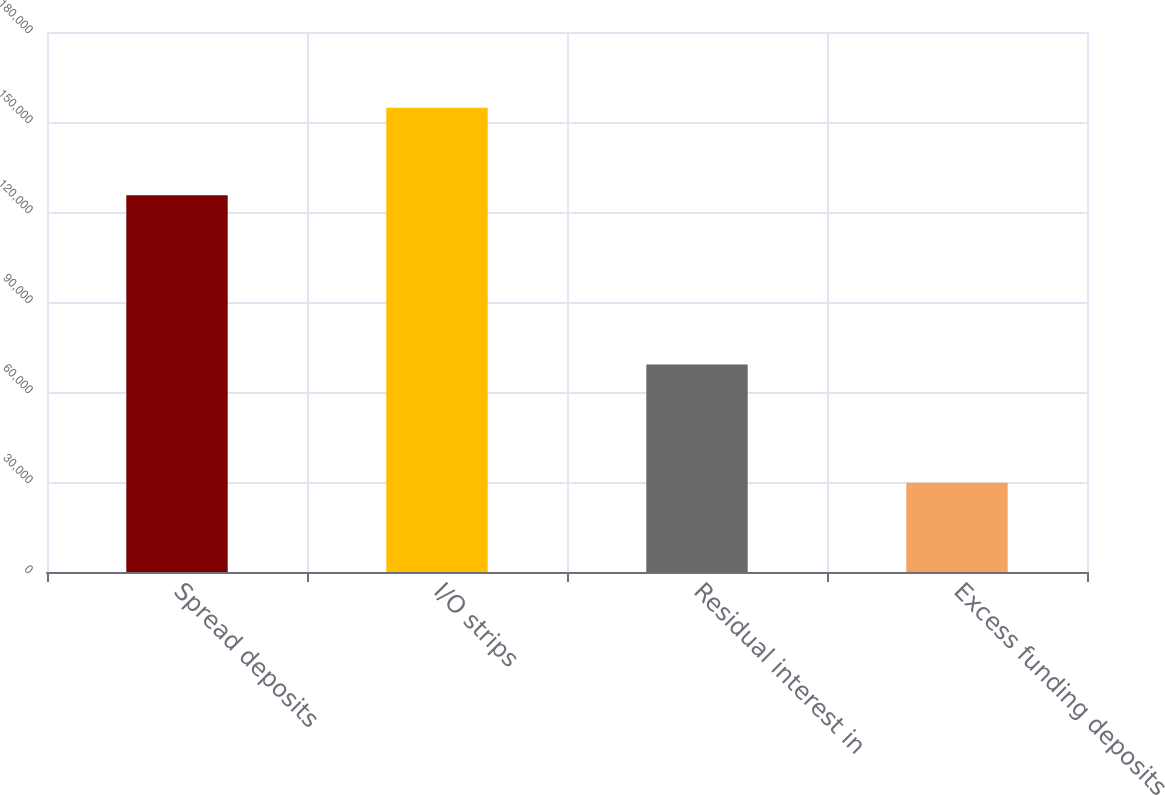Convert chart. <chart><loc_0><loc_0><loc_500><loc_500><bar_chart><fcel>Spread deposits<fcel>I/O strips<fcel>Residual interest in<fcel>Excess funding deposits<nl><fcel>125624<fcel>154735<fcel>69189<fcel>29720<nl></chart> 